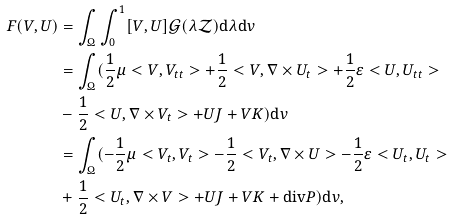Convert formula to latex. <formula><loc_0><loc_0><loc_500><loc_500>F ( V , U ) & = \int _ { \Omega } \int _ { 0 } ^ { 1 } [ V , U ] \mathcal { G } ( \lambda \mathcal { Z } ) \text {d} \lambda \text {d} v \\ & = \int _ { \Omega } ( \frac { 1 } { 2 } \mu < V , V _ { t t } > + \frac { 1 } { 2 } < V , \nabla \times U _ { t } > + \frac { 1 } { 2 } \varepsilon < U , U _ { t t } > \\ & - \frac { 1 } { 2 } < U , \nabla \times V _ { t } > + U J + V K ) \text {d} v \\ & = \int _ { \Omega } ( - \frac { 1 } { 2 } \mu < V _ { t } , V _ { t } > - \frac { 1 } { 2 } < V _ { t } , \nabla \times U > - \frac { 1 } { 2 } \varepsilon < U _ { t } , U _ { t } > \\ & + \frac { 1 } { 2 } < U _ { t } , \nabla \times V > + U J + V K + \text {div} P ) \text {d} v ,</formula> 